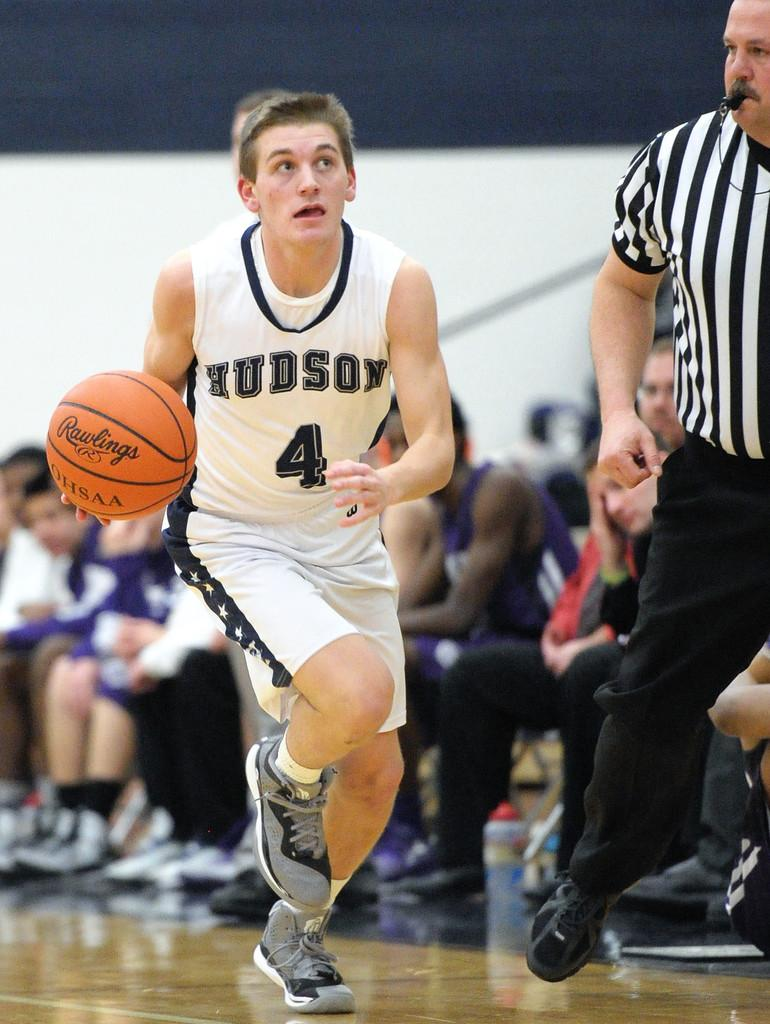<image>
Render a clear and concise summary of the photo. A basketball player wearing white and with the number 4 and name Hudson on his top runs withthe ball past the referee. 